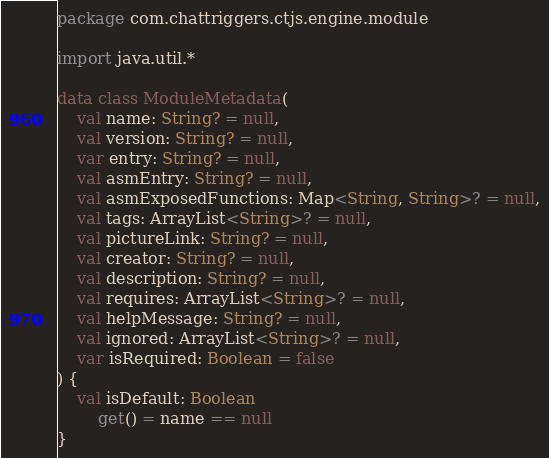Convert code to text. <code><loc_0><loc_0><loc_500><loc_500><_Kotlin_>package com.chattriggers.ctjs.engine.module

import java.util.*

data class ModuleMetadata(
    val name: String? = null,
    val version: String? = null,
    var entry: String? = null,
    val asmEntry: String? = null,
    val asmExposedFunctions: Map<String, String>? = null,
    val tags: ArrayList<String>? = null,
    val pictureLink: String? = null,
    val creator: String? = null,
    val description: String? = null,
    val requires: ArrayList<String>? = null,
    val helpMessage: String? = null,
    val ignored: ArrayList<String>? = null,
    var isRequired: Boolean = false
) {
    val isDefault: Boolean
        get() = name == null
}
</code> 